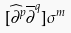<formula> <loc_0><loc_0><loc_500><loc_500>[ \widehat { \partial } ^ { p } \overline { \partial } ^ { q } ] \sigma ^ { m }</formula> 